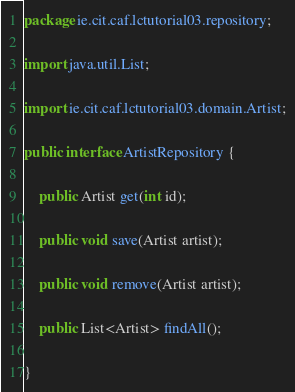Convert code to text. <code><loc_0><loc_0><loc_500><loc_500><_Java_>package ie.cit.caf.lctutorial03.repository;

import java.util.List;

import ie.cit.caf.lctutorial03.domain.Artist;

public interface ArtistRepository {
	
	public Artist get(int id);
	
	public void save(Artist artist);
	
	public void remove(Artist artist);
	
	public List<Artist> findAll();

}
</code> 